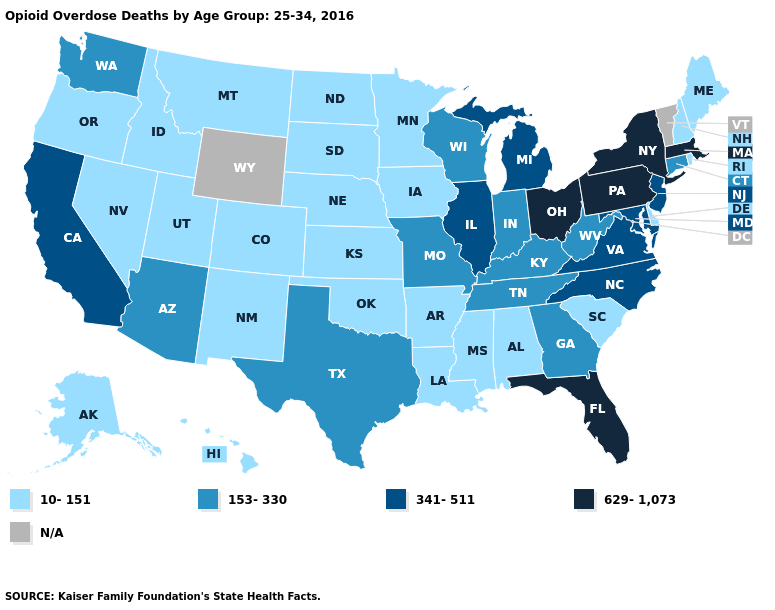Name the states that have a value in the range N/A?
Answer briefly. Vermont, Wyoming. Does Connecticut have the highest value in the Northeast?
Short answer required. No. How many symbols are there in the legend?
Write a very short answer. 5. Is the legend a continuous bar?
Be succinct. No. Does the map have missing data?
Be succinct. Yes. Name the states that have a value in the range 10-151?
Keep it brief. Alabama, Alaska, Arkansas, Colorado, Delaware, Hawaii, Idaho, Iowa, Kansas, Louisiana, Maine, Minnesota, Mississippi, Montana, Nebraska, Nevada, New Hampshire, New Mexico, North Dakota, Oklahoma, Oregon, Rhode Island, South Carolina, South Dakota, Utah. Name the states that have a value in the range 153-330?
Short answer required. Arizona, Connecticut, Georgia, Indiana, Kentucky, Missouri, Tennessee, Texas, Washington, West Virginia, Wisconsin. Does Connecticut have the lowest value in the Northeast?
Be succinct. No. What is the value of Arizona?
Quick response, please. 153-330. Is the legend a continuous bar?
Short answer required. No. What is the value of Florida?
Give a very brief answer. 629-1,073. What is the value of Nevada?
Write a very short answer. 10-151. 